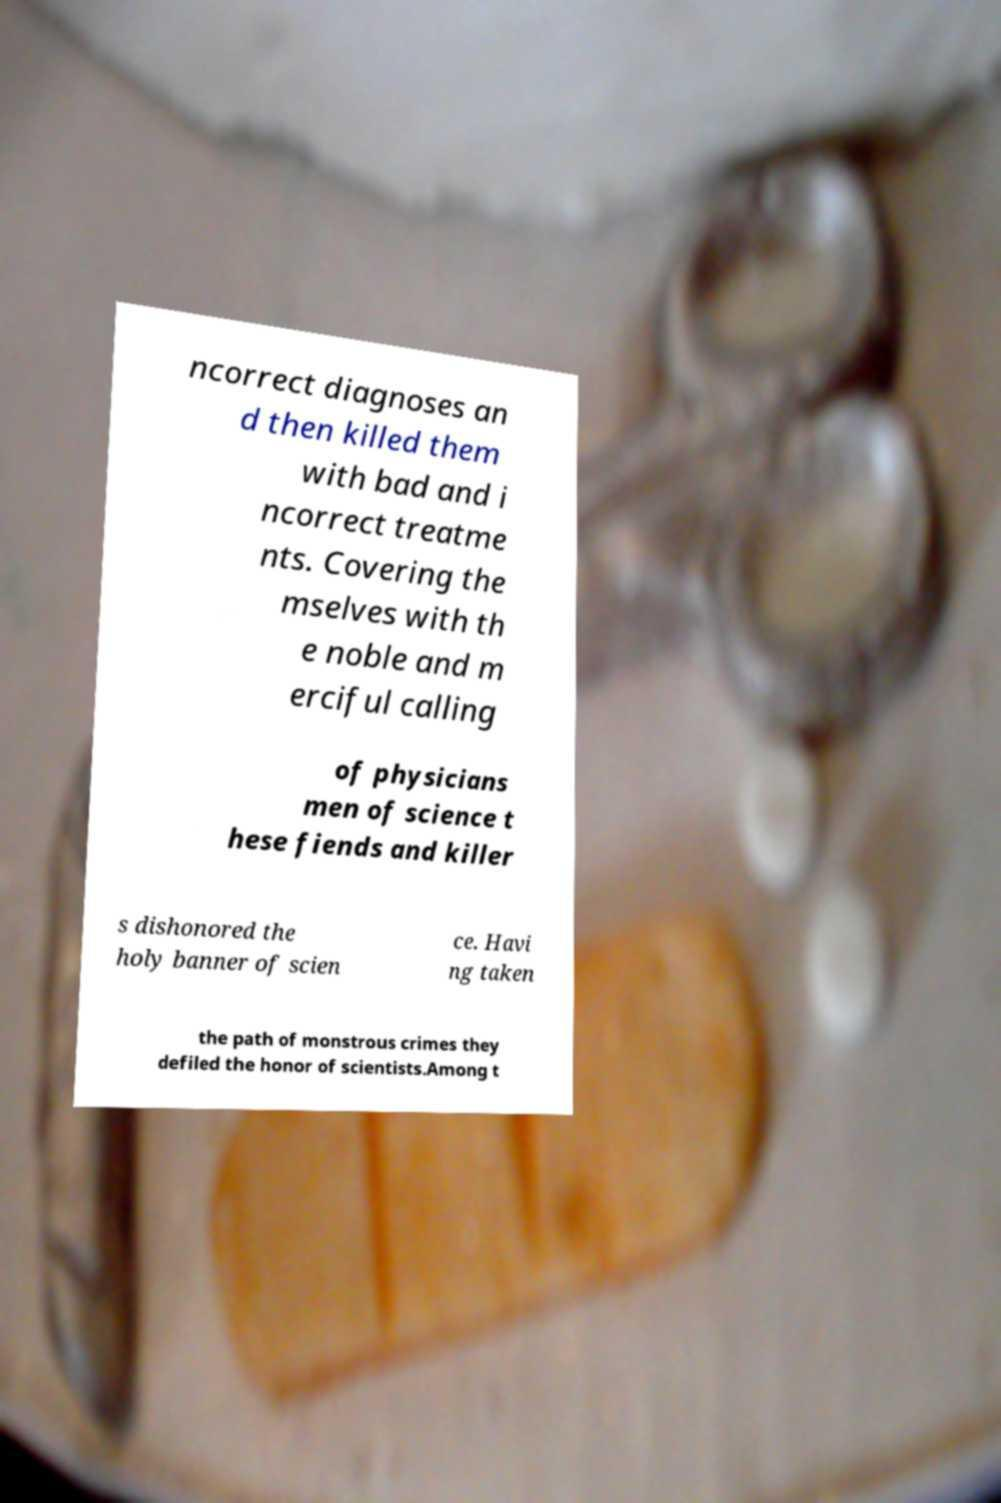Can you accurately transcribe the text from the provided image for me? ncorrect diagnoses an d then killed them with bad and i ncorrect treatme nts. Covering the mselves with th e noble and m erciful calling of physicians men of science t hese fiends and killer s dishonored the holy banner of scien ce. Havi ng taken the path of monstrous crimes they defiled the honor of scientists.Among t 